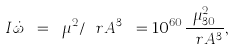Convert formula to latex. <formula><loc_0><loc_0><loc_500><loc_500>I \dot { \omega } \ = \ \mu ^ { 2 } / \ r A ^ { 3 } \ = 1 0 ^ { 6 0 } \frac { \mu _ { 3 0 } ^ { 2 } } { \ r A ^ { 3 } } ,</formula> 